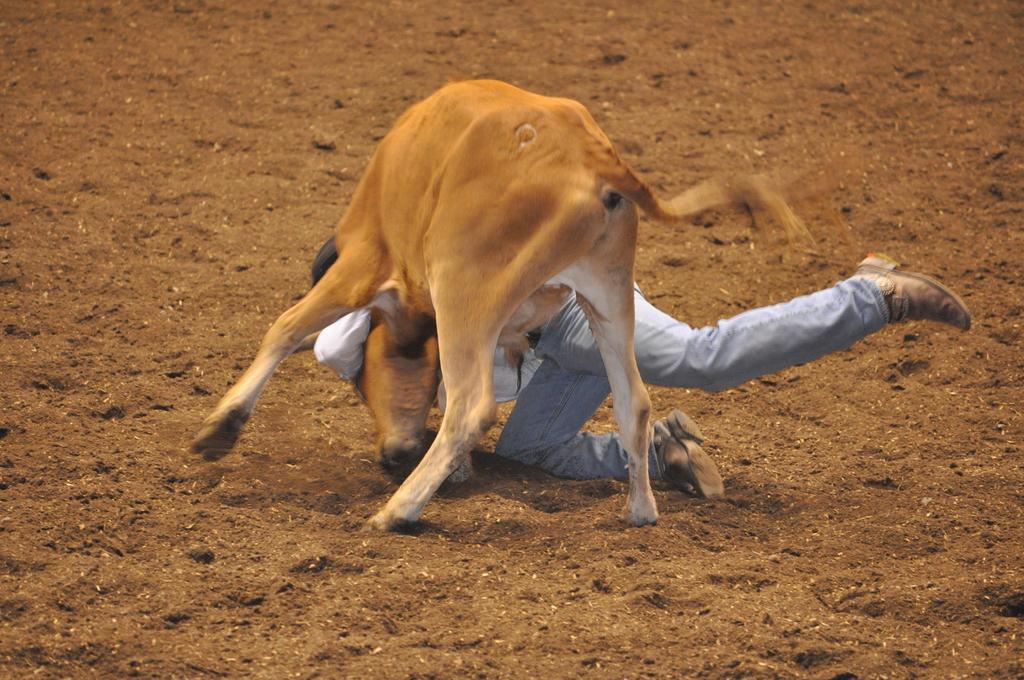Describe this image in one or two sentences. In this picture we can see a calf and a person on the ground. 